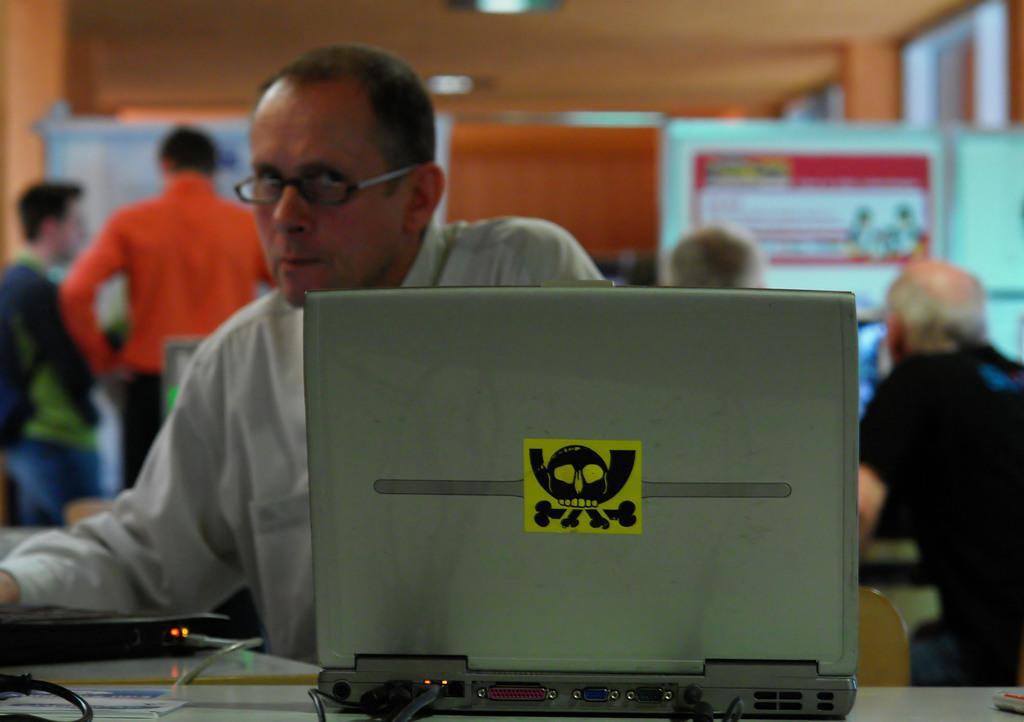Describe this image in one or two sentences. At the top we can see ceiling. In this picture we can see a poster and a board. We can see people standing. We can see a man wearing white shirt, he wore spectacles. Beside to him we can see people. On the table we can see a laptop, paper, wire, an electronic device and in the bottom right corner we can see an object. 